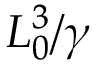Convert formula to latex. <formula><loc_0><loc_0><loc_500><loc_500>L _ { 0 } ^ { 3 } / \gamma</formula> 